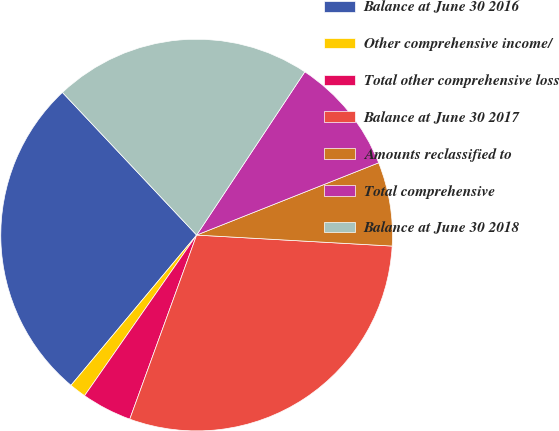Convert chart to OTSL. <chart><loc_0><loc_0><loc_500><loc_500><pie_chart><fcel>Balance at June 30 2016<fcel>Other comprehensive income/<fcel>Total other comprehensive loss<fcel>Balance at June 30 2017<fcel>Amounts reclassified to<fcel>Total comprehensive<fcel>Balance at June 30 2018<nl><fcel>26.9%<fcel>1.39%<fcel>4.15%<fcel>29.65%<fcel>6.91%<fcel>9.67%<fcel>21.33%<nl></chart> 